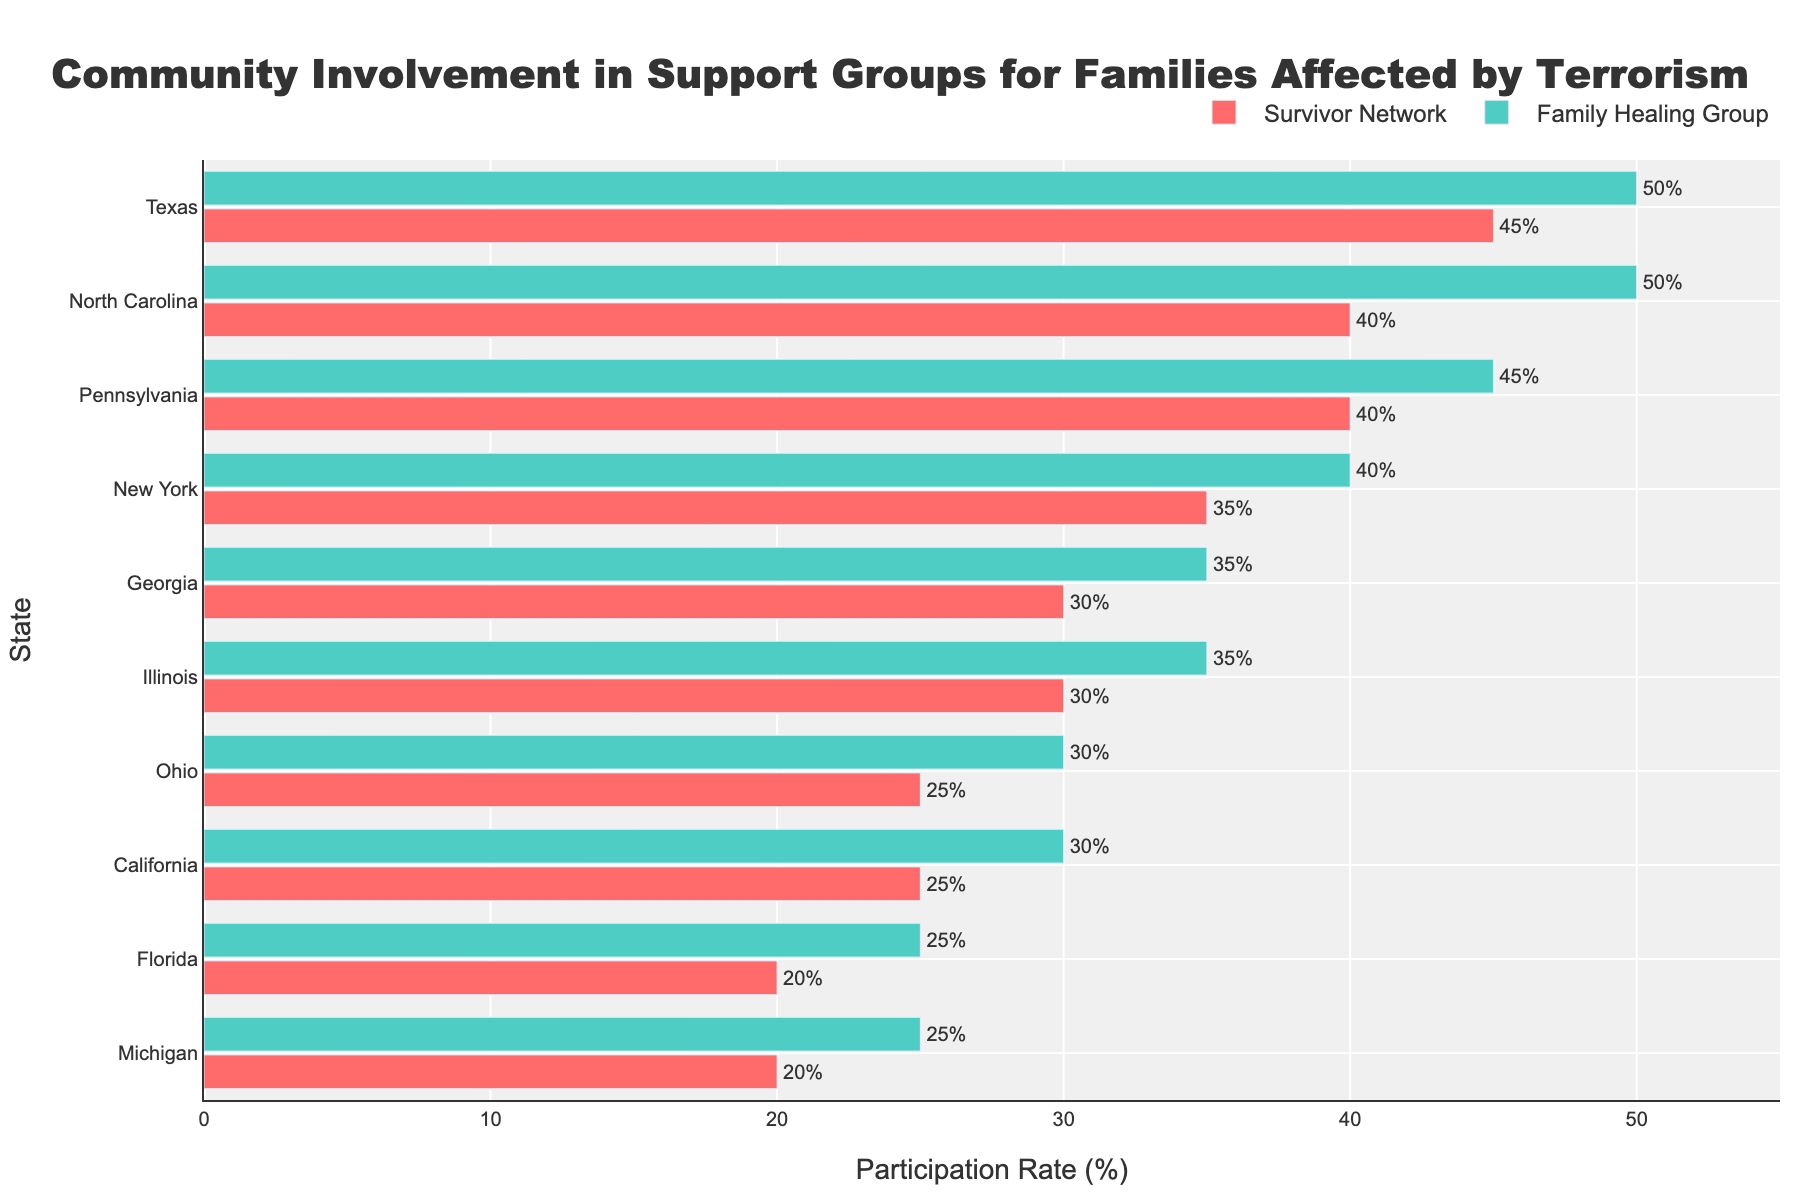1. Which state has the highest participation rate in the Family Healing Group? The bar for the Family Healing Group with the highest percentage is noted in the graph. By observing the length and height of the bars, North Carolina shows the highest participation rate.
Answer: North Carolina 2. What is the difference in participation rates between the Survivor Network and the Family Healing Group in Texas? By looking at the bars for Texas, the Survivor Network has a participation rate of 45%, and the Family Healing Group has a 50% participation rate. The difference between these values is calculated as 50% - 45% = 5%.
Answer: 5% 3. In which state does the Survivor Network have the lowest participation rate? The lowest bar for the Survivor Network group appears in Florida.
Answer: Florida 4. By how much does the participation rate in the Family Healing Group in Illinois exceed that of the Survivor Network in the same state? In Illinois, the bars show that the Survivor Network has a 30% participation rate, and the Family Healing Group has a 35% participation rate. The excess is calculated as 35% - 30% = 5%.
Answer: 5% 5. What is the average participation rate for the Family Healing Group in Michigan and Florida combined? For Michigan, the Family Healing Group has a 25% participation rate, and for Florida, it is 25%. The average is calculated as (25% + 25%) / 2 = 25%.
Answer: 25% 6. How many states have a participation rate of 40% or more in any support group? By scanning the bars, the states with a 40% or more rate are Texas (45% and 50%), Pennsylvania (40% and 45%), North Carolina (40% and 50%), and New York (40%). Thus, there are 4 states.
Answer: 4 7. What is the participation rate difference between the highest and lowest states in the Survivor Network? The highest participation in the Survivor Network is in Texas (45%), and the lowest is in Florida (20%). The difference is calculated as 45% - 20% = 25%.
Answer: 25% 8. Which support group shows more consistent participation rates across all states? By comparing the bar lengths, the Family Healing Group consistently shows slightly higher or comparable participation rates across all states in contrast to the more varied rates of the Survivor Network.
Answer: Family Healing Group 9. What is the overall range of participation rates in the Family Healing Group across all states? The highest participation rate in the Family Healing Group is 50% (North Carolina and Texas), and the lowest is 25% (Florida and Michigan), so the range is 50% - 25% = 25%.
Answer: 25% 10. Which state has the smallest difference in participation rates between the two support groups? By observing the bars for each state, Ohio shows the smallest difference, with the Survivor Network at 25% and the Family Healing Group at 30%, a difference of 5%, which is the smallest observed.
Answer: Ohio 